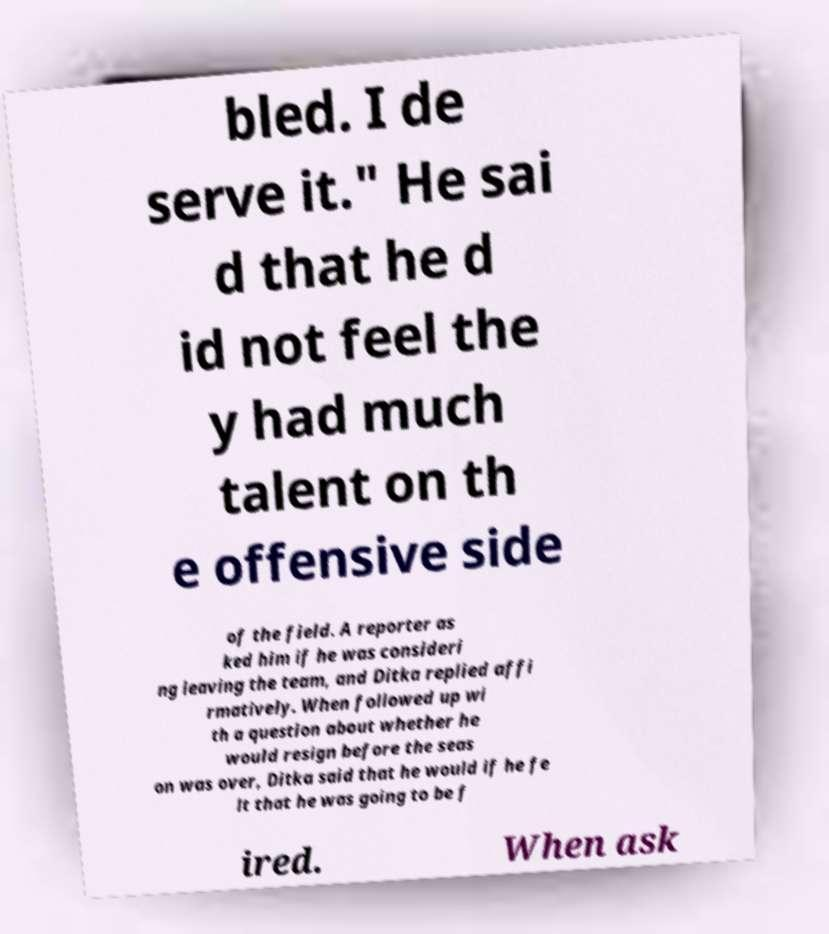Can you accurately transcribe the text from the provided image for me? bled. I de serve it." He sai d that he d id not feel the y had much talent on th e offensive side of the field. A reporter as ked him if he was consideri ng leaving the team, and Ditka replied affi rmatively. When followed up wi th a question about whether he would resign before the seas on was over, Ditka said that he would if he fe lt that he was going to be f ired. When ask 